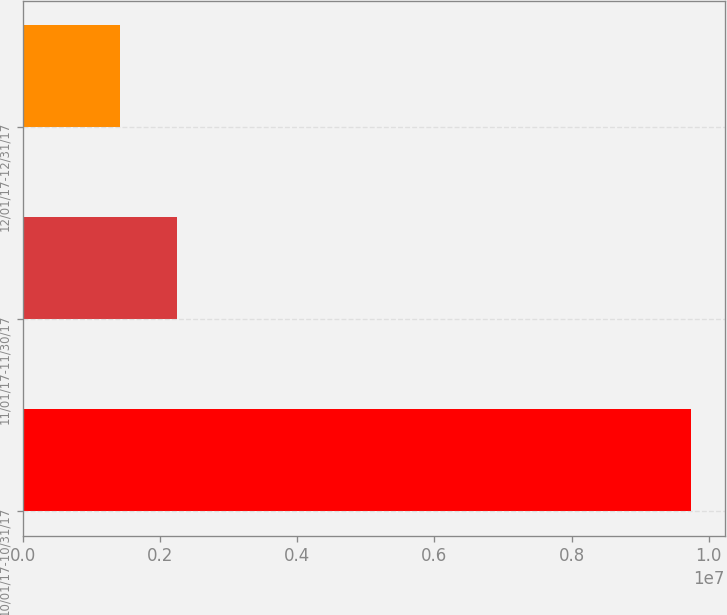Convert chart. <chart><loc_0><loc_0><loc_500><loc_500><bar_chart><fcel>10/01/17-10/31/17<fcel>11/01/17-11/30/17<fcel>12/01/17-12/31/17<nl><fcel>9.74698e+06<fcel>2.25569e+06<fcel>1.42332e+06<nl></chart> 